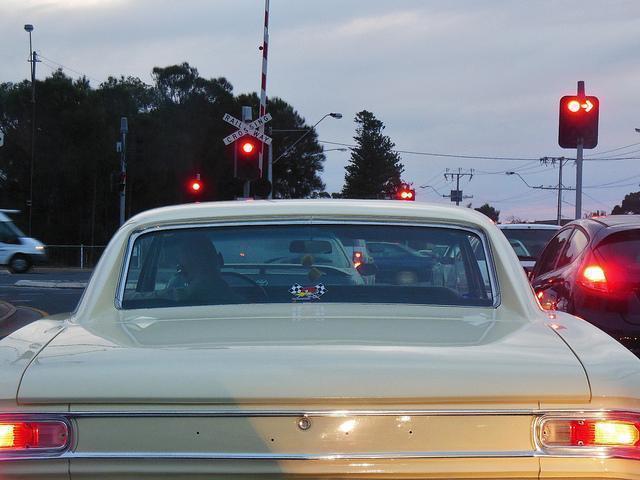There are a line of cars at the intersection because of what reason?
Choose the correct response and explain in the format: 'Answer: answer
Rationale: rationale.'
Options: Emergency vehicle, traffic light, approaching train, traffic jam. Answer: traffic light.
Rationale: The cars are in traffic. 